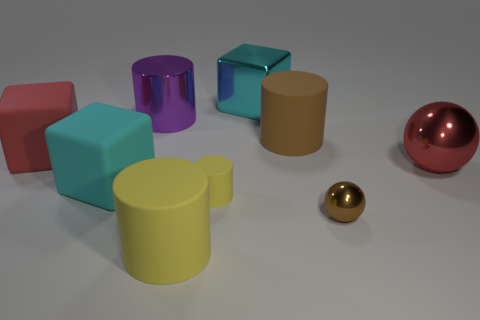Imagine these objects were part of a game, what kind of game could it be? Envisioning these objects in a game, they could serve as playing pieces for a strategic board game, akin to chess but with a twist. Each shape could have unique movement patterns or abilities, and the ultimate goal could be to reach a certain position on the board or capture other shapes. Their different sizes and colors could also play into the game mechanics, representing different ranks or powers. 